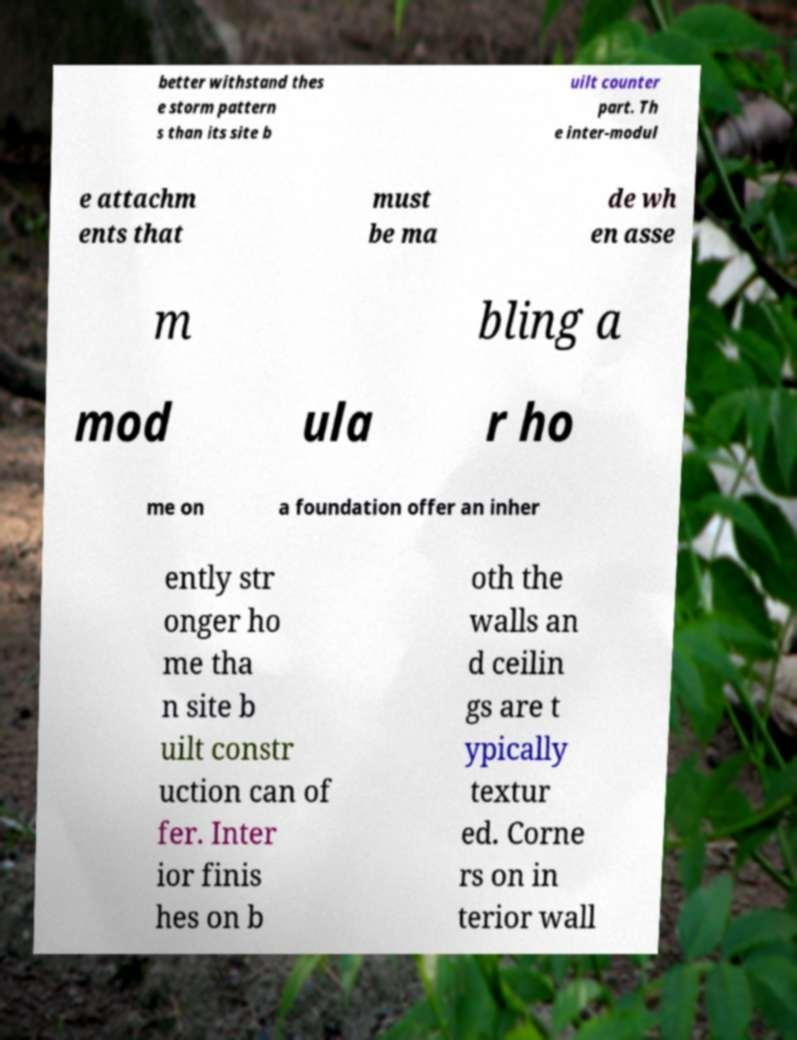What messages or text are displayed in this image? I need them in a readable, typed format. better withstand thes e storm pattern s than its site b uilt counter part. Th e inter-modul e attachm ents that must be ma de wh en asse m bling a mod ula r ho me on a foundation offer an inher ently str onger ho me tha n site b uilt constr uction can of fer. Inter ior finis hes on b oth the walls an d ceilin gs are t ypically textur ed. Corne rs on in terior wall 